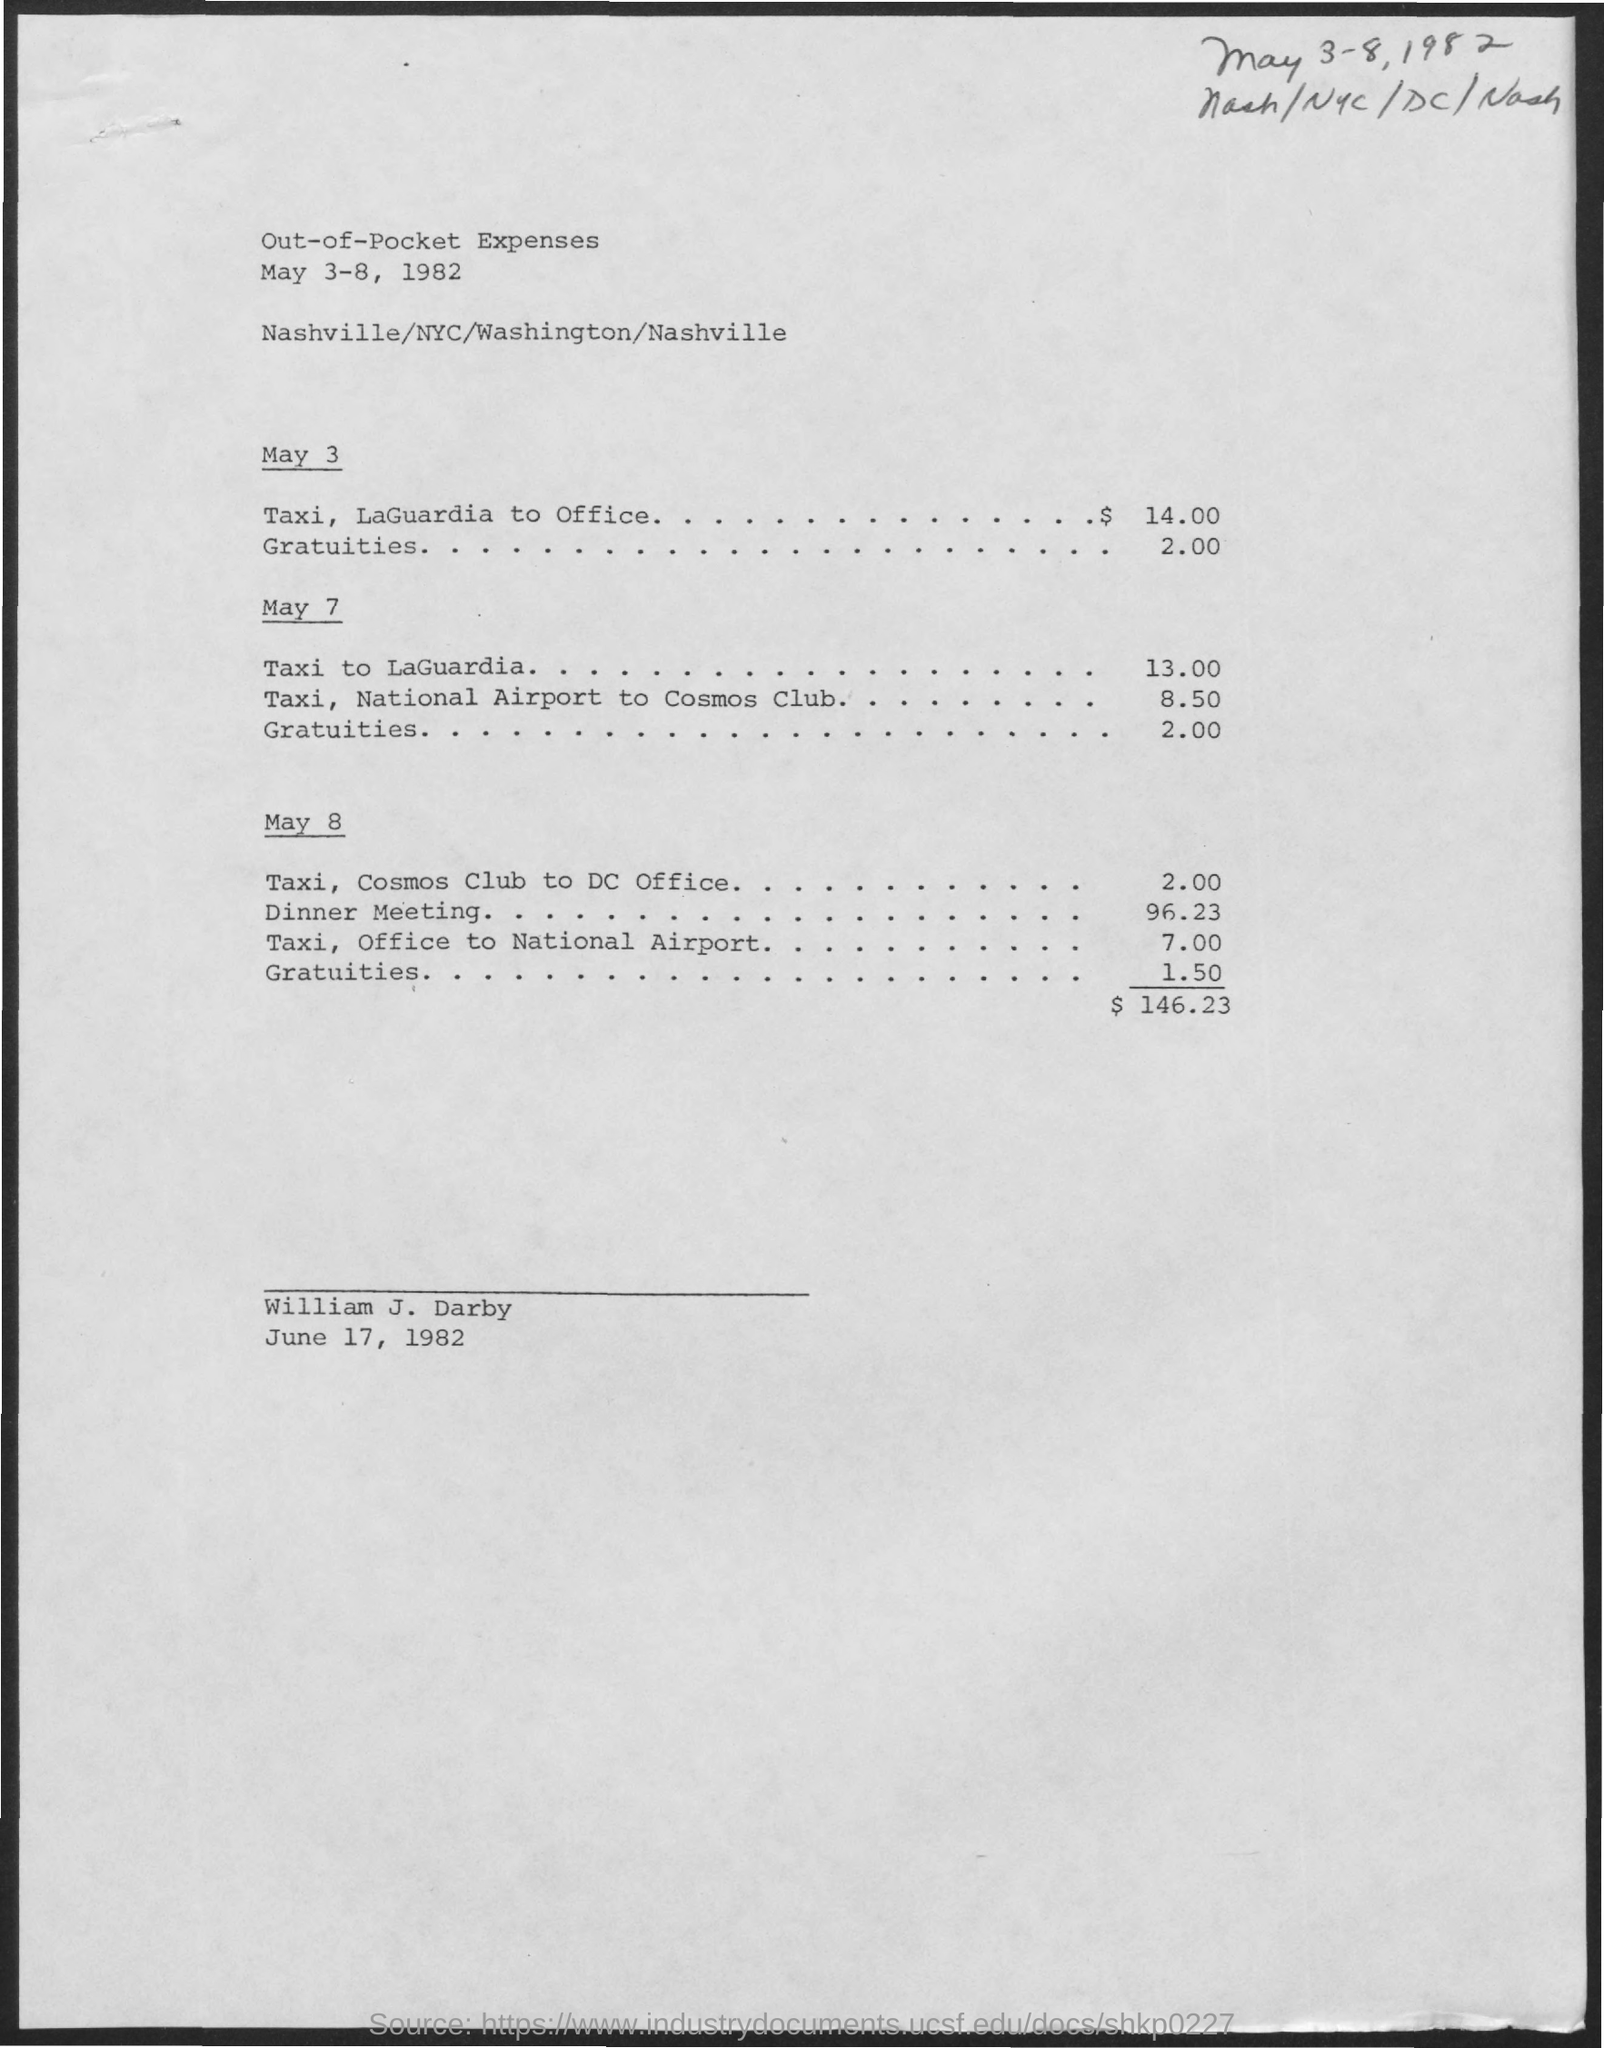Outline some significant characteristics in this image. The taxi fare from the National airport to the Cosmos club on May 7 is 8.50. On May 8, the taxi fare from the Office to the National Airport is 7.00. On May 8, the taxi fare from the Cosmos club to the DC Office is 2.00. The date mentioned at the bottom of the document is June 17, 1982. The person mentioned in the document is named William J. Darby. 